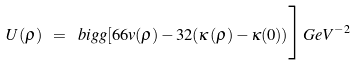<formula> <loc_0><loc_0><loc_500><loc_500>U ( \rho ) \ = \ b i g g [ 6 6 v ( \rho ) - 3 2 ( \kappa ( \rho ) - \kappa ( 0 ) ) \Big ] G e V ^ { - 2 }</formula> 